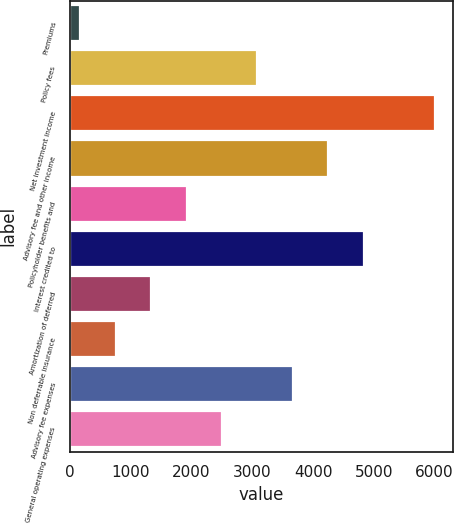<chart> <loc_0><loc_0><loc_500><loc_500><bar_chart><fcel>Premiums<fcel>Policy fees<fcel>Net investment income<fcel>Advisory fee and other income<fcel>Policyholder benefits and<fcel>Interest credited to<fcel>Amortization of deferred<fcel>Non deferrable insurance<fcel>Advisory fee expenses<fcel>General operating expenses<nl><fcel>168<fcel>3085<fcel>6002<fcel>4251.8<fcel>1918.2<fcel>4835.2<fcel>1334.8<fcel>751.4<fcel>3668.4<fcel>2501.6<nl></chart> 